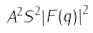<formula> <loc_0><loc_0><loc_500><loc_500>A ^ { 2 } S ^ { 2 } | F ( q ) | ^ { 2 }</formula> 